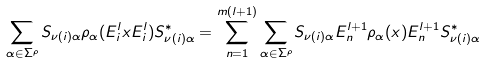<formula> <loc_0><loc_0><loc_500><loc_500>\sum _ { \alpha \in \Sigma ^ { \rho } } S _ { \nu ( i ) \alpha } \rho _ { \alpha } ( E _ { i } ^ { l } x E _ { i } ^ { l } ) S _ { \nu ( i ) \alpha } ^ { * } = \sum _ { n = 1 } ^ { m ( l + 1 ) } \sum _ { \alpha \in \Sigma ^ { \rho } } S _ { \nu ( i ) \alpha } E _ { n } ^ { l + 1 } \rho _ { \alpha } ( x ) E _ { n } ^ { l + 1 } S _ { \nu ( i ) \alpha } ^ { * }</formula> 